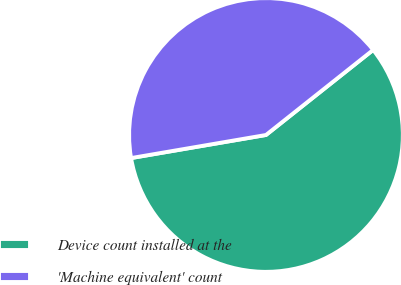Convert chart to OTSL. <chart><loc_0><loc_0><loc_500><loc_500><pie_chart><fcel>Device count installed at the<fcel>'Machine equivalent' count<nl><fcel>57.98%<fcel>42.02%<nl></chart> 